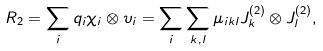<formula> <loc_0><loc_0><loc_500><loc_500>R _ { 2 } = \sum _ { i } q _ { i } \chi _ { i } \otimes \upsilon _ { i } = \sum _ { i } \sum _ { k , l } \mu _ { i k l } J _ { k } ^ { ( 2 ) } \otimes J _ { l } ^ { ( 2 ) } ,</formula> 